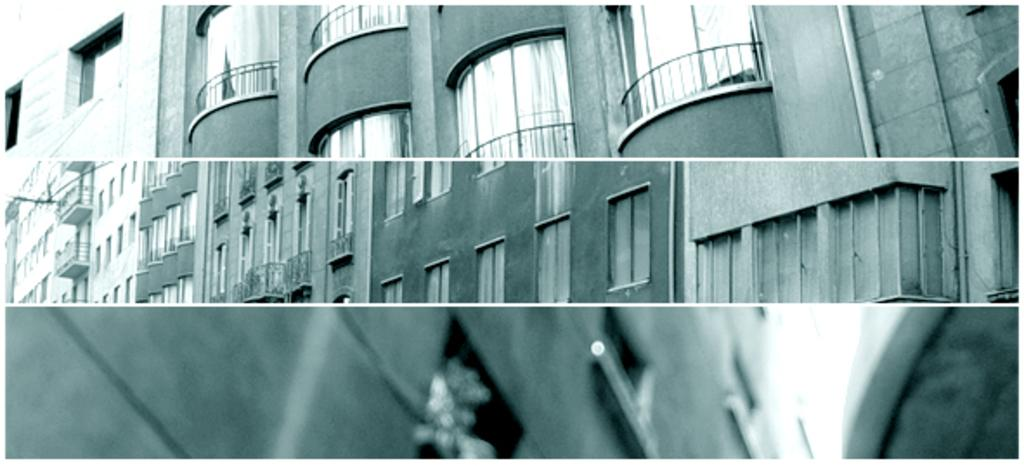What type of image is shown in the collage? The image is a collage of images. What subjects are featured in the collage? Multiple buildings are depicted in the collage. What color scheme is used in the collage? The image is in black and white. What position does the queen hold in the collage? There is no queen present in the collage; it features multiple buildings. What is the texture of the chin in the collage? There is no chin present in the collage; it is a collection of images of buildings. 